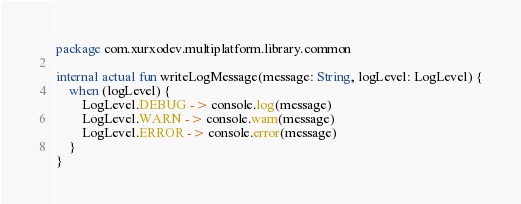<code> <loc_0><loc_0><loc_500><loc_500><_Kotlin_>package com.xurxodev.multiplatform.library.common

internal actual fun writeLogMessage(message: String, logLevel: LogLevel) {
    when (logLevel) {
        LogLevel.DEBUG -> console.log(message)
        LogLevel.WARN -> console.warn(message)
        LogLevel.ERROR -> console.error(message)
    }
}
</code> 